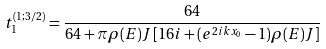Convert formula to latex. <formula><loc_0><loc_0><loc_500><loc_500>t _ { 1 } ^ { ( 1 ; 3 / 2 ) } = \frac { 6 4 } { 6 4 + \pi \rho ( E ) J \, [ 1 6 i + ( e ^ { 2 i k x _ { 0 } } - 1 ) \rho ( E ) J ] }</formula> 